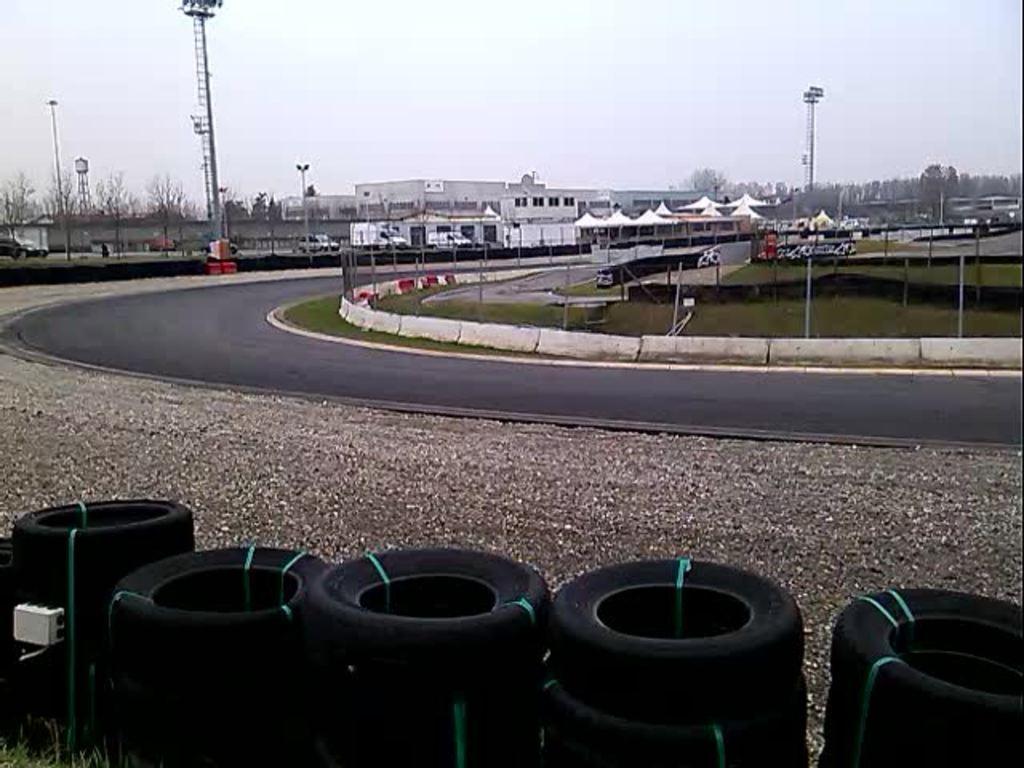Can you describe this image briefly? This picture is clicked outside the city. At the bottom of the picture, we see tyres. Beside that, we see a road. On the right side, we see grey and black color tents. Beside that, we see poles. On the left side, we see vehicles moving on the road. Beside that, we see a tower and poles. There are buildings in the background. We even see electric pole and a tower. There are trees and poles in the background. At the top of the picture, we see the sky. 